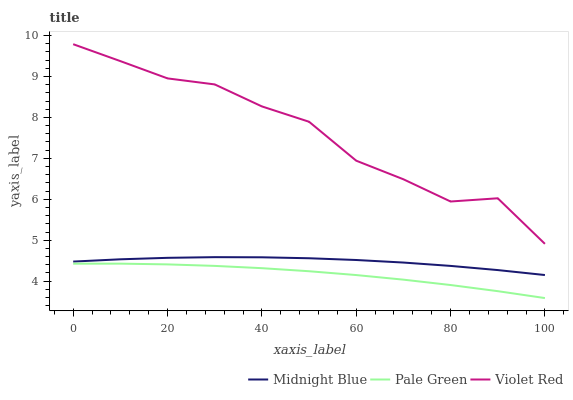Does Pale Green have the minimum area under the curve?
Answer yes or no. Yes. Does Violet Red have the maximum area under the curve?
Answer yes or no. Yes. Does Midnight Blue have the minimum area under the curve?
Answer yes or no. No. Does Midnight Blue have the maximum area under the curve?
Answer yes or no. No. Is Pale Green the smoothest?
Answer yes or no. Yes. Is Violet Red the roughest?
Answer yes or no. Yes. Is Midnight Blue the smoothest?
Answer yes or no. No. Is Midnight Blue the roughest?
Answer yes or no. No. Does Pale Green have the lowest value?
Answer yes or no. Yes. Does Midnight Blue have the lowest value?
Answer yes or no. No. Does Violet Red have the highest value?
Answer yes or no. Yes. Does Midnight Blue have the highest value?
Answer yes or no. No. Is Midnight Blue less than Violet Red?
Answer yes or no. Yes. Is Violet Red greater than Midnight Blue?
Answer yes or no. Yes. Does Midnight Blue intersect Violet Red?
Answer yes or no. No. 